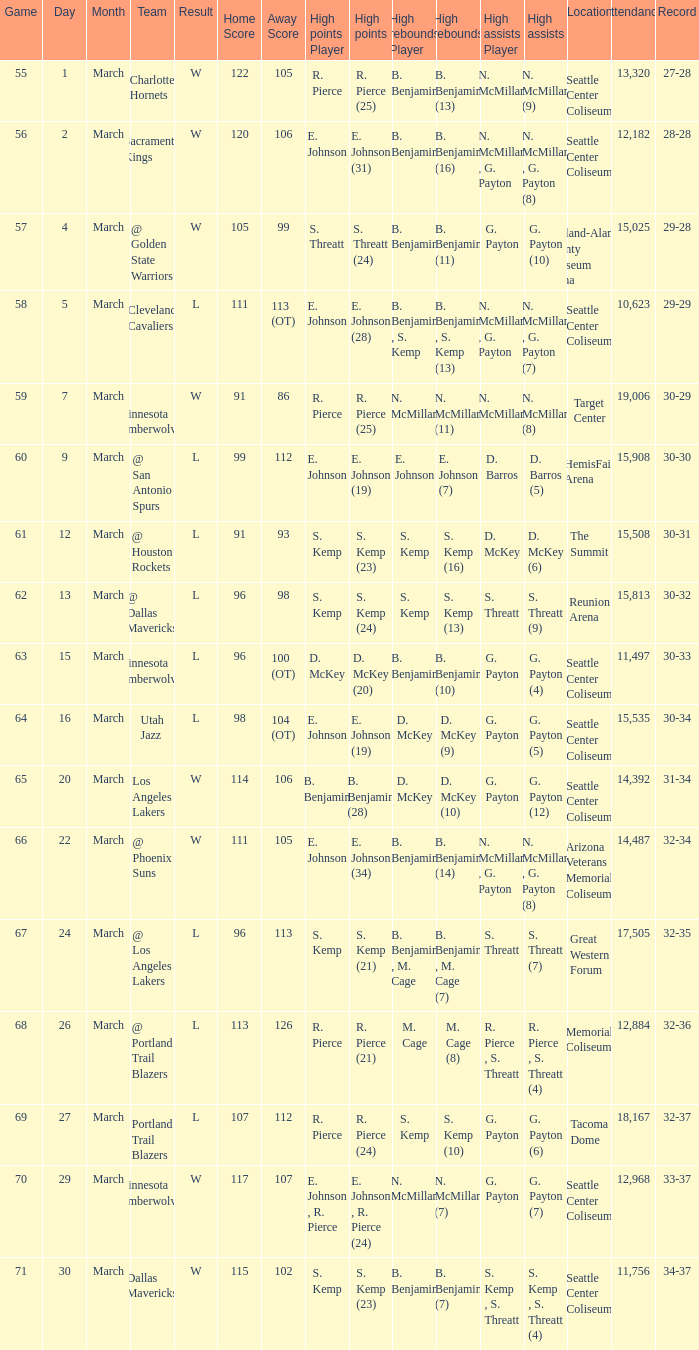Which Game has a Team of portland trail blazers? 69.0. Can you give me this table as a dict? {'header': ['Game', 'Day', 'Month', 'Team', 'Result', 'Home Score', 'Away Score', 'High points Player', 'High points', 'High rebounds Player', 'High rebounds', 'High assists Player', 'High assists', 'Location', 'Attendance', 'Record'], 'rows': [['55', '1', 'March', 'Charlotte Hornets', 'W', '122', '105', 'R. Pierce', 'R. Pierce (25)', 'B. Benjamin', 'B. Benjamin (13)', 'N. McMillan', 'N. McMillan (9)', 'Seattle Center Coliseum', '13,320', '27-28'], ['56', '2', 'March', 'Sacramento Kings', 'W', '120', '106', 'E. Johnson', 'E. Johnson (31)', 'B. Benjamin', 'B. Benjamin (16)', 'N. McMillan , G. Payton', 'N. McMillan , G. Payton (8)', 'Seattle Center Coliseum', '12,182', '28-28'], ['57', '4', 'March', '@ Golden State Warriors', 'W', '105', '99', 'S. Threatt', 'S. Threatt (24)', 'B. Benjamin', 'B. Benjamin (11)', 'G. Payton', 'G. Payton (10)', 'Oakland-Alameda County Coliseum Arena', '15,025', '29-28'], ['58', '5', 'March', 'Cleveland Cavaliers', 'L', '111', '113 (OT)', 'E. Johnson', 'E. Johnson (28)', 'B. Benjamin , S. Kemp', 'B. Benjamin , S. Kemp (13)', 'N. McMillan , G. Payton', 'N. McMillan , G. Payton (7)', 'Seattle Center Coliseum', '10,623', '29-29'], ['59', '7', 'March', '@ Minnesota Timberwolves', 'W', '91', '86', 'R. Pierce', 'R. Pierce (25)', 'N. McMillan', 'N. McMillan (11)', 'N. McMillan', 'N. McMillan (8)', 'Target Center', '19,006', '30-29'], ['60', '9', 'March', '@ San Antonio Spurs', 'L', '99', '112', 'E. Johnson', 'E. Johnson (19)', 'E. Johnson', 'E. Johnson (7)', 'D. Barros', 'D. Barros (5)', 'HemisFair Arena', '15,908', '30-30'], ['61', '12', 'March', '@ Houston Rockets', 'L', '91', '93', 'S. Kemp', 'S. Kemp (23)', 'S. Kemp', 'S. Kemp (16)', 'D. McKey', 'D. McKey (6)', 'The Summit', '15,508', '30-31'], ['62', '13', 'March', '@ Dallas Mavericks', 'L', '96', '98', 'S. Kemp', 'S. Kemp (24)', 'S. Kemp', 'S. Kemp (13)', 'S. Threatt', 'S. Threatt (9)', 'Reunion Arena', '15,813', '30-32'], ['63', '15', 'March', 'Minnesota Timberwolves', 'L', '96', '100 (OT)', 'D. McKey', 'D. McKey (20)', 'B. Benjamin', 'B. Benjamin (10)', 'G. Payton', 'G. Payton (4)', 'Seattle Center Coliseum', '11,497', '30-33'], ['64', '16', 'March', 'Utah Jazz', 'L', '98', '104 (OT)', 'E. Johnson', 'E. Johnson (19)', 'D. McKey', 'D. McKey (9)', 'G. Payton', 'G. Payton (5)', 'Seattle Center Coliseum', '15,535', '30-34'], ['65', '20', 'March', 'Los Angeles Lakers', 'W', '114', '106', 'B. Benjamin', 'B. Benjamin (28)', 'D. McKey', 'D. McKey (10)', 'G. Payton', 'G. Payton (12)', 'Seattle Center Coliseum', '14,392', '31-34'], ['66', '22', 'March', '@ Phoenix Suns', 'W', '111', '105', 'E. Johnson', 'E. Johnson (34)', 'B. Benjamin', 'B. Benjamin (14)', 'N. McMillan , G. Payton', 'N. McMillan , G. Payton (8)', 'Arizona Veterans Memorial Coliseum', '14,487', '32-34'], ['67', '24', 'March', '@ Los Angeles Lakers', 'L', '96', '113', 'S. Kemp', 'S. Kemp (21)', 'B. Benjamin , M. Cage', 'B. Benjamin , M. Cage (7)', 'S. Threatt', 'S. Threatt (7)', 'Great Western Forum', '17,505', '32-35'], ['68', '26', 'March', '@ Portland Trail Blazers', 'L', '113', '126', 'R. Pierce', 'R. Pierce (21)', 'M. Cage', 'M. Cage (8)', 'R. Pierce , S. Threatt', 'R. Pierce , S. Threatt (4)', 'Memorial Coliseum', '12,884', '32-36'], ['69', '27', 'March', 'Portland Trail Blazers', 'L', '107', '112', 'R. Pierce', 'R. Pierce (24)', 'S. Kemp', 'S. Kemp (10)', 'G. Payton', 'G. Payton (6)', 'Tacoma Dome', '18,167', '32-37'], ['70', '29', 'March', 'Minnesota Timberwolves', 'W', '117', '107', 'E. Johnson , R. Pierce', 'E. Johnson , R. Pierce (24)', 'N. McMillan', 'N. McMillan (7)', 'G. Payton', 'G. Payton (7)', 'Seattle Center Coliseum', '12,968', '33-37'], ['71', '30', 'March', 'Dallas Mavericks', 'W', '115', '102', 'S. Kemp', 'S. Kemp (23)', 'B. Benjamin', 'B. Benjamin (7)', 'S. Kemp , S. Threatt', 'S. Kemp , S. Threatt (4)', 'Seattle Center Coliseum', '11,756', '34-37']]} 